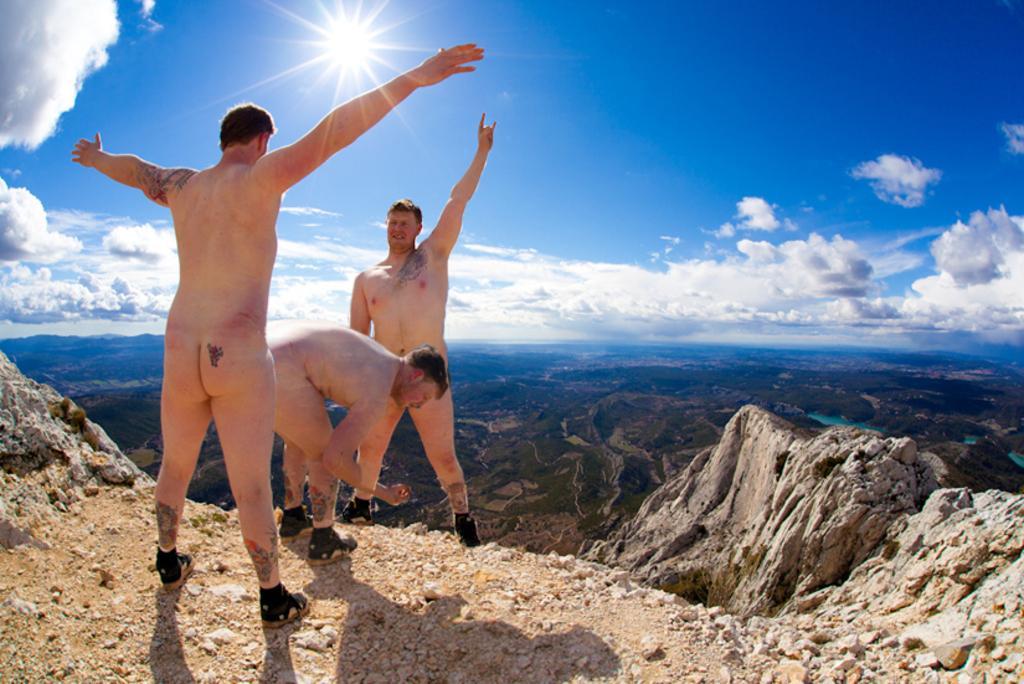Could you give a brief overview of what you see in this image? There are three people and these two people are standing. Background we can see sky with clouds. 